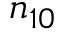Convert formula to latex. <formula><loc_0><loc_0><loc_500><loc_500>n _ { 1 0 }</formula> 